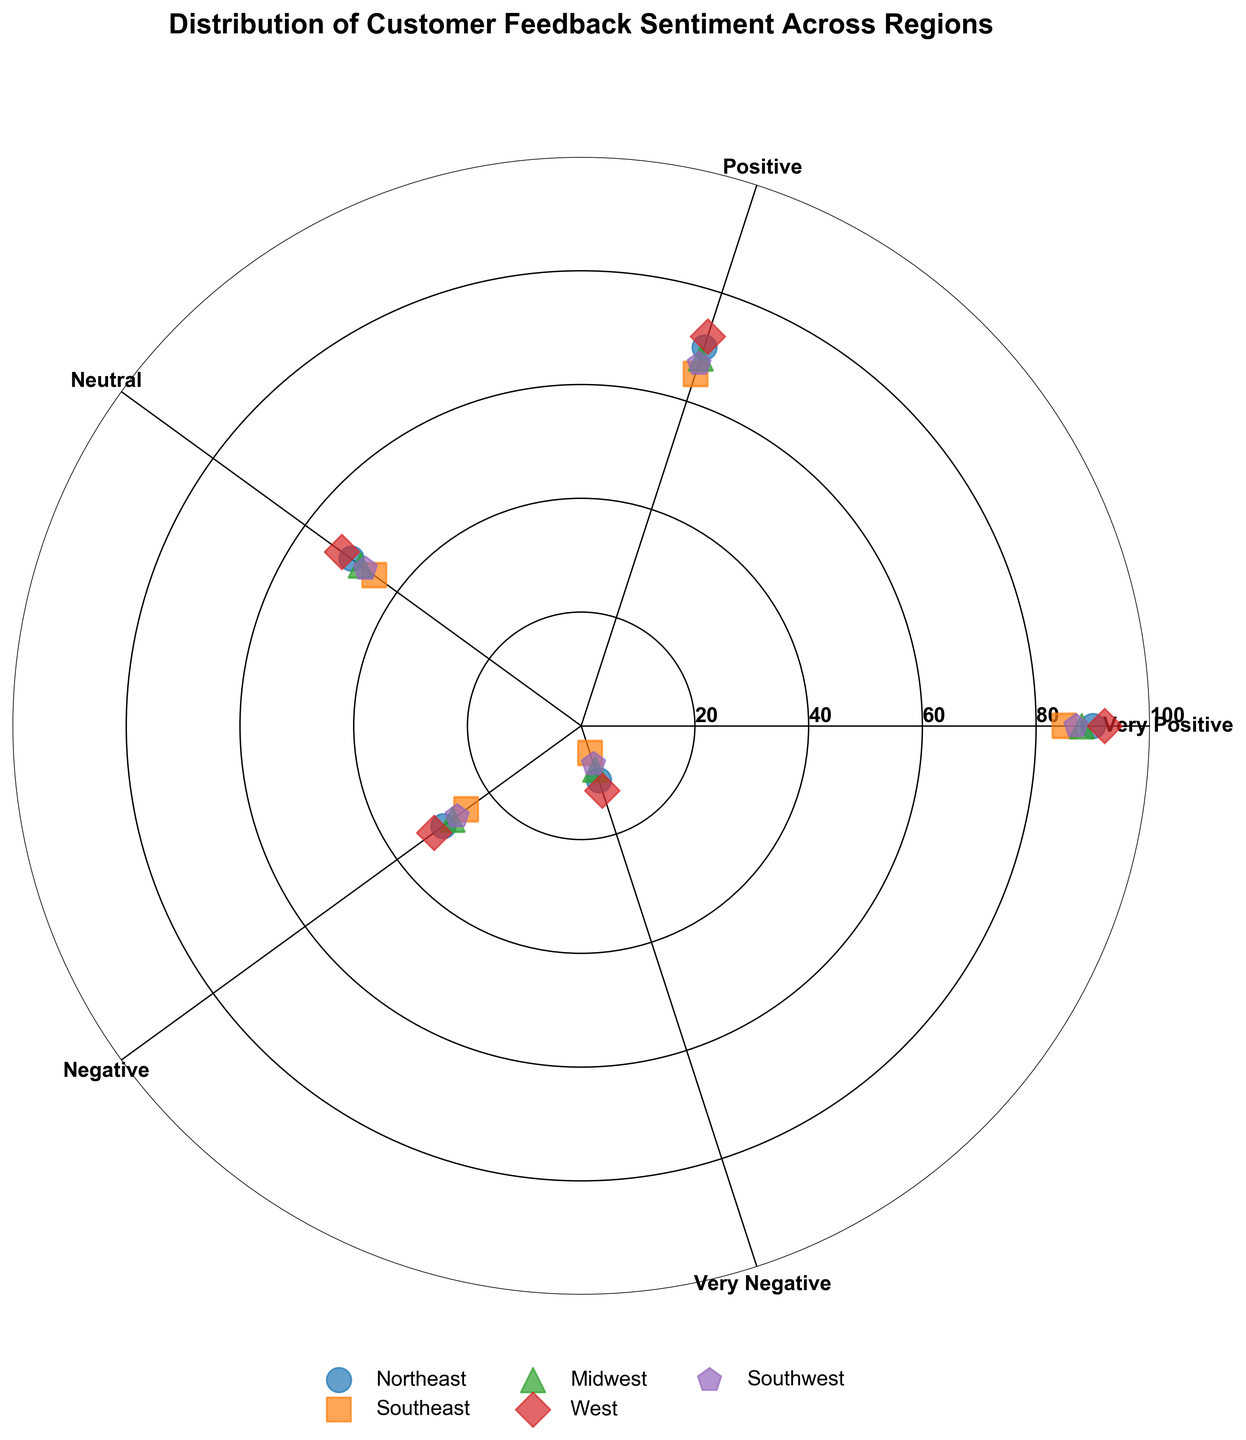what is the title of the figure? The title is displayed at the top of the figure. By reading it, we find that it states "Distribution of Customer Feedback Sentiment Across Regions"
Answer: Distribution of Customer Feedback Sentiment Across Regions How many regions are represented in the figure? By observing the legend in the figure, we can count the number of different regions mentioned, each indicated by a distinct symbol and color. There are five regions listed.
Answer: Five What is the highest sentiment score recorded in the figure, and which region does it belong to? In the figure, the highest sentiment score can be seen as the point furthest from the center. By observing this, the point with the highest radial distance belongs to the West region, with a score of 92.
Answer: 92, West Which region has the lowest sentiment score for Very Negative feedback? By looking at the points representing Very Negative feedback on the plot, the score closest to the center is 5. The legend indicates this point belongs to the Southeast region.
Answer: Southeast How many sentiment labels are represented on the chart? The sentiment labels are indicated around the outer circular axis (theta) of the chart. By counting these labels, we find there are five sentiments represented.
Answer: Five In which region are the sentiments more concentrated around the "Positive" score compared to other regions? By inspecting the vicinity of the "Positive" label in the figure, more points that are close to this label can be seen for the "West" region (score of 72), indicating higher concentration compared to other regions.
Answer: West Which region shows the smallest change in scores between Very Positive and Very Negative sentiments? To find this, calculate the score difference for each region between the Very Positive and Very Negative sentiments. The differences are 80 (Northeast: 90-10), 80 (Southeast: 85-5), 80 (Midwest: 88-8), 80 (West: 92-12), and 80 (Southwest: 87-7). The differences are equivalent across all regions.
Answer: All regions What is the average score for Positive feedback across all regions? Average is calculated by summing all Positive scores and dividing by the number of regions. The Positive scores are 70 (Northeast), 65 (Southeast), 68 (Midwest), 72 (West), and 67 (Southwest). Average = (70+65+68+72+67)/5 = 68.4
Answer: 68.4 Which region has the most balanced distribution of sentiment scores? A balanced distribution would have the scores evenly spread out across sentiment categories. By observing the scatter of points on the chart across each region, Midwest appears to have scores more evenly spaced from center to outer circle across sentiment categories compared to others.
Answer: Midwest What is the range of sentiment scores in the Northeast region? The range is the difference between the maximum and minimum scores in the Northeast. These scores are 90 (Very Positive) and 10 (Very Negative). Range = 90 - 10 = 80
Answer: 80 